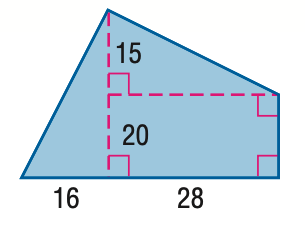Answer the mathemtical geometry problem and directly provide the correct option letter.
Question: Find the area of the figure. Round to the nearest tenth, if necessary.
Choices: A: 740 B: 840 C: 1050 D: 1540 C 